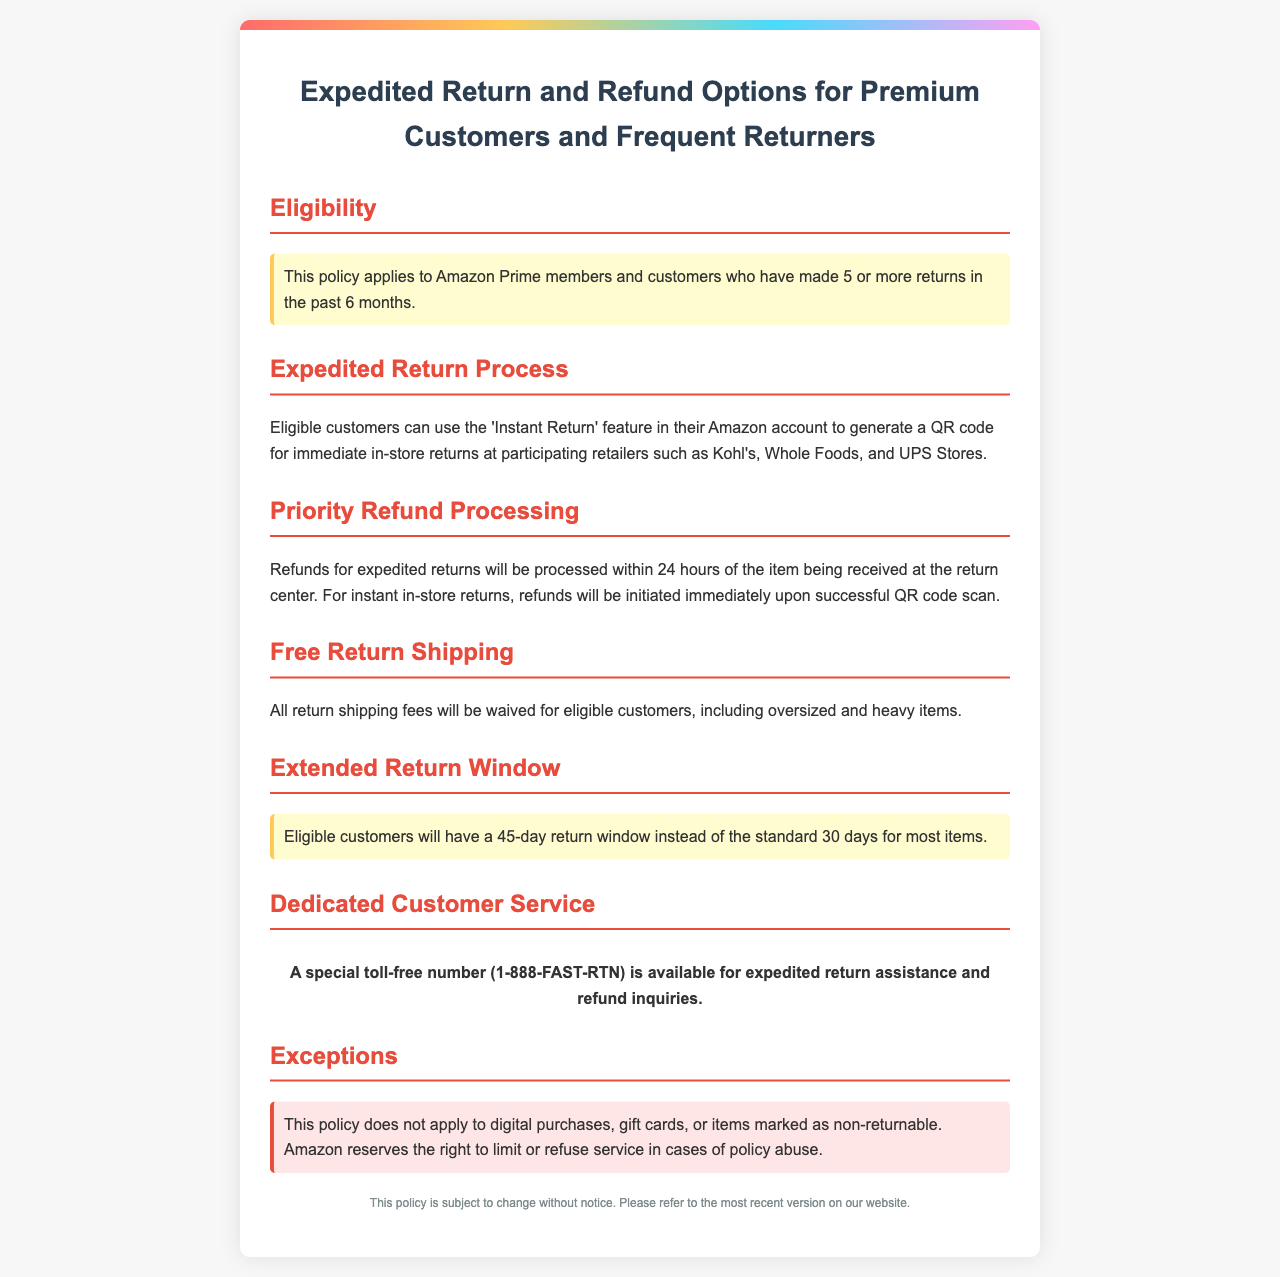What is the eligibility for the expedited return policy? Eligibility is defined by whether customers are Amazon Prime members or have made 5 or more returns in the past 6 months.
Answer: Amazon Prime members and customers who have made 5 or more returns in the past 6 months What is the return window for eligible customers? The document states that eligible customers will have a 45-day return window instead of the standard 30 days for most items.
Answer: 45 days What feature can eligible customers use for in-store returns? The policy mentions the 'Instant Return' feature which allows customers to generate a QR code for returns.
Answer: Instant Return How long will refunds be processed for expedited returns? Refunds for expedited returns will be processed within 24 hours of the item being received at the return center.
Answer: 24 hours What number should customers call for expedited return inquiries? The document provides a special toll-free number for expedited return assistance.
Answer: 1-888-FAST-RTN What items are exceptions to the return policy? The document outlines exclusions, specifying which types of purchases do not qualify for this policy.
Answer: Digital purchases, gift cards, or items marked as non-returnable What type of items have waived return shipping fees? The policy states that all return shipping fees will be waived for eligible customers.
Answer: All return shipping fees What happens after a successful QR code scan for returns? The document states that refunds will be initiated immediately upon successful QR code scan.
Answer: Refunds will be initiated immediately 